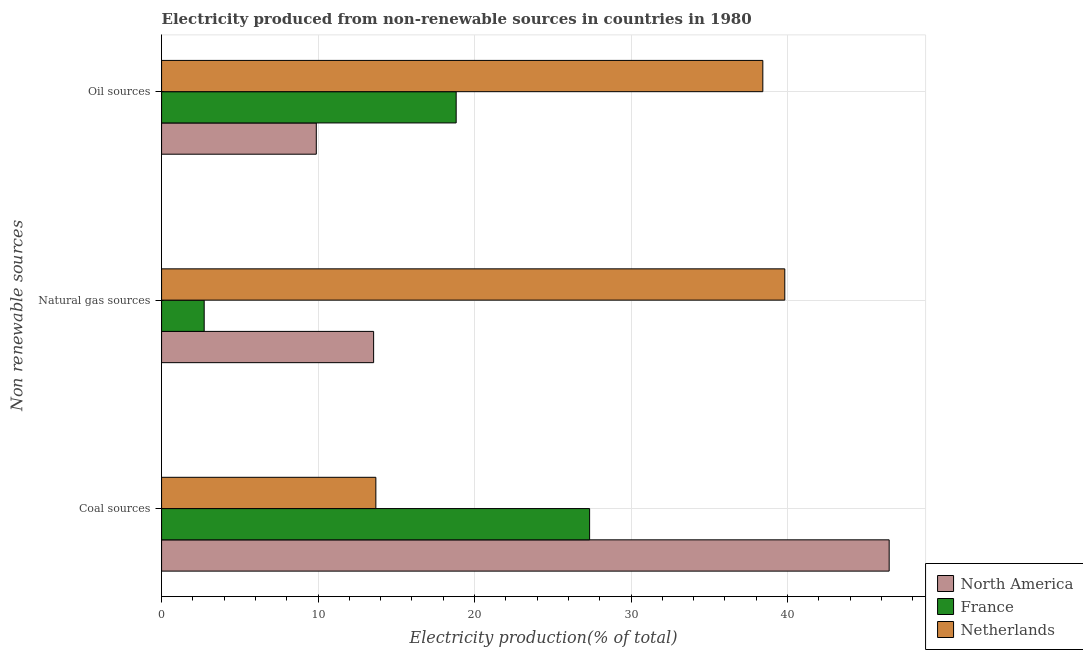How many different coloured bars are there?
Offer a terse response. 3. Are the number of bars per tick equal to the number of legend labels?
Offer a terse response. Yes. Are the number of bars on each tick of the Y-axis equal?
Your answer should be very brief. Yes. How many bars are there on the 1st tick from the top?
Ensure brevity in your answer.  3. How many bars are there on the 1st tick from the bottom?
Provide a short and direct response. 3. What is the label of the 1st group of bars from the top?
Your answer should be very brief. Oil sources. What is the percentage of electricity produced by coal in France?
Provide a short and direct response. 27.35. Across all countries, what is the maximum percentage of electricity produced by coal?
Your response must be concise. 46.49. Across all countries, what is the minimum percentage of electricity produced by coal?
Offer a very short reply. 13.69. In which country was the percentage of electricity produced by coal maximum?
Offer a very short reply. North America. In which country was the percentage of electricity produced by coal minimum?
Your response must be concise. Netherlands. What is the total percentage of electricity produced by coal in the graph?
Your response must be concise. 87.54. What is the difference between the percentage of electricity produced by oil sources in North America and that in France?
Ensure brevity in your answer.  -8.94. What is the difference between the percentage of electricity produced by coal in Netherlands and the percentage of electricity produced by oil sources in North America?
Keep it short and to the point. 3.81. What is the average percentage of electricity produced by coal per country?
Give a very brief answer. 29.18. What is the difference between the percentage of electricity produced by natural gas and percentage of electricity produced by coal in North America?
Provide a short and direct response. -32.94. In how many countries, is the percentage of electricity produced by coal greater than 44 %?
Keep it short and to the point. 1. What is the ratio of the percentage of electricity produced by coal in France to that in North America?
Your answer should be compact. 0.59. Is the percentage of electricity produced by oil sources in France less than that in North America?
Ensure brevity in your answer.  No. What is the difference between the highest and the second highest percentage of electricity produced by oil sources?
Provide a succinct answer. 19.6. What is the difference between the highest and the lowest percentage of electricity produced by oil sources?
Your response must be concise. 28.53. What does the 3rd bar from the top in Oil sources represents?
Provide a short and direct response. North America. What does the 3rd bar from the bottom in Oil sources represents?
Make the answer very short. Netherlands. How many bars are there?
Provide a short and direct response. 9. What is the difference between two consecutive major ticks on the X-axis?
Keep it short and to the point. 10. Are the values on the major ticks of X-axis written in scientific E-notation?
Give a very brief answer. No. Does the graph contain any zero values?
Provide a short and direct response. No. What is the title of the graph?
Provide a short and direct response. Electricity produced from non-renewable sources in countries in 1980. Does "Tuvalu" appear as one of the legend labels in the graph?
Keep it short and to the point. No. What is the label or title of the Y-axis?
Keep it short and to the point. Non renewable sources. What is the Electricity production(% of total) in North America in Coal sources?
Provide a short and direct response. 46.49. What is the Electricity production(% of total) of France in Coal sources?
Keep it short and to the point. 27.35. What is the Electricity production(% of total) of Netherlands in Coal sources?
Give a very brief answer. 13.69. What is the Electricity production(% of total) of North America in Natural gas sources?
Provide a short and direct response. 13.55. What is the Electricity production(% of total) of France in Natural gas sources?
Offer a terse response. 2.72. What is the Electricity production(% of total) of Netherlands in Natural gas sources?
Keep it short and to the point. 39.83. What is the Electricity production(% of total) in North America in Oil sources?
Make the answer very short. 9.89. What is the Electricity production(% of total) of France in Oil sources?
Offer a very short reply. 18.83. What is the Electricity production(% of total) of Netherlands in Oil sources?
Provide a short and direct response. 38.42. Across all Non renewable sources, what is the maximum Electricity production(% of total) in North America?
Your response must be concise. 46.49. Across all Non renewable sources, what is the maximum Electricity production(% of total) of France?
Your answer should be very brief. 27.35. Across all Non renewable sources, what is the maximum Electricity production(% of total) of Netherlands?
Your answer should be very brief. 39.83. Across all Non renewable sources, what is the minimum Electricity production(% of total) of North America?
Offer a very short reply. 9.89. Across all Non renewable sources, what is the minimum Electricity production(% of total) in France?
Offer a very short reply. 2.72. Across all Non renewable sources, what is the minimum Electricity production(% of total) of Netherlands?
Provide a short and direct response. 13.69. What is the total Electricity production(% of total) of North America in the graph?
Provide a succinct answer. 69.93. What is the total Electricity production(% of total) of France in the graph?
Provide a short and direct response. 48.9. What is the total Electricity production(% of total) of Netherlands in the graph?
Keep it short and to the point. 91.94. What is the difference between the Electricity production(% of total) in North America in Coal sources and that in Natural gas sources?
Provide a succinct answer. 32.94. What is the difference between the Electricity production(% of total) of France in Coal sources and that in Natural gas sources?
Make the answer very short. 24.63. What is the difference between the Electricity production(% of total) in Netherlands in Coal sources and that in Natural gas sources?
Ensure brevity in your answer.  -26.13. What is the difference between the Electricity production(% of total) of North America in Coal sources and that in Oil sources?
Make the answer very short. 36.61. What is the difference between the Electricity production(% of total) of France in Coal sources and that in Oil sources?
Make the answer very short. 8.53. What is the difference between the Electricity production(% of total) of Netherlands in Coal sources and that in Oil sources?
Your response must be concise. -24.73. What is the difference between the Electricity production(% of total) of North America in Natural gas sources and that in Oil sources?
Your answer should be very brief. 3.66. What is the difference between the Electricity production(% of total) of France in Natural gas sources and that in Oil sources?
Offer a very short reply. -16.1. What is the difference between the Electricity production(% of total) in Netherlands in Natural gas sources and that in Oil sources?
Offer a terse response. 1.4. What is the difference between the Electricity production(% of total) of North America in Coal sources and the Electricity production(% of total) of France in Natural gas sources?
Make the answer very short. 43.77. What is the difference between the Electricity production(% of total) of North America in Coal sources and the Electricity production(% of total) of Netherlands in Natural gas sources?
Offer a very short reply. 6.67. What is the difference between the Electricity production(% of total) of France in Coal sources and the Electricity production(% of total) of Netherlands in Natural gas sources?
Your answer should be compact. -12.47. What is the difference between the Electricity production(% of total) of North America in Coal sources and the Electricity production(% of total) of France in Oil sources?
Provide a succinct answer. 27.67. What is the difference between the Electricity production(% of total) in North America in Coal sources and the Electricity production(% of total) in Netherlands in Oil sources?
Provide a short and direct response. 8.07. What is the difference between the Electricity production(% of total) of France in Coal sources and the Electricity production(% of total) of Netherlands in Oil sources?
Ensure brevity in your answer.  -11.07. What is the difference between the Electricity production(% of total) in North America in Natural gas sources and the Electricity production(% of total) in France in Oil sources?
Give a very brief answer. -5.27. What is the difference between the Electricity production(% of total) in North America in Natural gas sources and the Electricity production(% of total) in Netherlands in Oil sources?
Provide a succinct answer. -24.87. What is the difference between the Electricity production(% of total) of France in Natural gas sources and the Electricity production(% of total) of Netherlands in Oil sources?
Ensure brevity in your answer.  -35.7. What is the average Electricity production(% of total) of North America per Non renewable sources?
Give a very brief answer. 23.31. What is the average Electricity production(% of total) of France per Non renewable sources?
Your answer should be very brief. 16.3. What is the average Electricity production(% of total) of Netherlands per Non renewable sources?
Ensure brevity in your answer.  30.65. What is the difference between the Electricity production(% of total) in North America and Electricity production(% of total) in France in Coal sources?
Make the answer very short. 19.14. What is the difference between the Electricity production(% of total) in North America and Electricity production(% of total) in Netherlands in Coal sources?
Give a very brief answer. 32.8. What is the difference between the Electricity production(% of total) in France and Electricity production(% of total) in Netherlands in Coal sources?
Your answer should be compact. 13.66. What is the difference between the Electricity production(% of total) in North America and Electricity production(% of total) in France in Natural gas sources?
Your response must be concise. 10.83. What is the difference between the Electricity production(% of total) in North America and Electricity production(% of total) in Netherlands in Natural gas sources?
Give a very brief answer. -26.27. What is the difference between the Electricity production(% of total) of France and Electricity production(% of total) of Netherlands in Natural gas sources?
Ensure brevity in your answer.  -37.1. What is the difference between the Electricity production(% of total) of North America and Electricity production(% of total) of France in Oil sources?
Your answer should be very brief. -8.94. What is the difference between the Electricity production(% of total) of North America and Electricity production(% of total) of Netherlands in Oil sources?
Ensure brevity in your answer.  -28.53. What is the difference between the Electricity production(% of total) of France and Electricity production(% of total) of Netherlands in Oil sources?
Your answer should be very brief. -19.6. What is the ratio of the Electricity production(% of total) in North America in Coal sources to that in Natural gas sources?
Your answer should be very brief. 3.43. What is the ratio of the Electricity production(% of total) in France in Coal sources to that in Natural gas sources?
Your answer should be very brief. 10.05. What is the ratio of the Electricity production(% of total) in Netherlands in Coal sources to that in Natural gas sources?
Your answer should be compact. 0.34. What is the ratio of the Electricity production(% of total) of North America in Coal sources to that in Oil sources?
Keep it short and to the point. 4.7. What is the ratio of the Electricity production(% of total) in France in Coal sources to that in Oil sources?
Ensure brevity in your answer.  1.45. What is the ratio of the Electricity production(% of total) in Netherlands in Coal sources to that in Oil sources?
Make the answer very short. 0.36. What is the ratio of the Electricity production(% of total) in North America in Natural gas sources to that in Oil sources?
Your response must be concise. 1.37. What is the ratio of the Electricity production(% of total) in France in Natural gas sources to that in Oil sources?
Your response must be concise. 0.14. What is the ratio of the Electricity production(% of total) of Netherlands in Natural gas sources to that in Oil sources?
Keep it short and to the point. 1.04. What is the difference between the highest and the second highest Electricity production(% of total) of North America?
Keep it short and to the point. 32.94. What is the difference between the highest and the second highest Electricity production(% of total) in France?
Provide a succinct answer. 8.53. What is the difference between the highest and the second highest Electricity production(% of total) in Netherlands?
Provide a short and direct response. 1.4. What is the difference between the highest and the lowest Electricity production(% of total) of North America?
Keep it short and to the point. 36.61. What is the difference between the highest and the lowest Electricity production(% of total) of France?
Provide a short and direct response. 24.63. What is the difference between the highest and the lowest Electricity production(% of total) in Netherlands?
Keep it short and to the point. 26.13. 